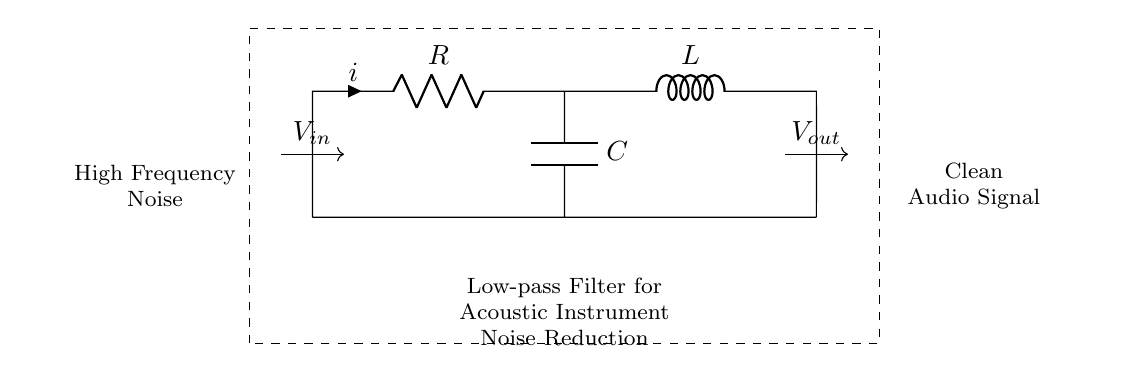What are the components used in this circuit? The circuit consists of a resistor, an inductor, and a capacitor, commonly found in low-pass filters. Visually, they are labeled R, L, and C.
Answer: Resistor, Inductor, Capacitor What is the input signal type for this circuit? The input signal is labeled as V_in, and the diagram indicates it deals with high-frequency noise, suggesting it is an alternating current signal used in audio applications.
Answer: High-frequency noise Where is the output taken from in the circuit? The output is taken from V_out, which is positioned after the inductor in the circuit diagram, providing the cleaned signal.
Answer: After the inductor How does the inductor affect the circuit's frequency response? The inductor opposes changes in current, leading to a reduced response to high frequencies while allowing lower frequencies to pass through, characteristic of a low-pass filter's function.
Answer: Reduces high frequencies What is the primary function of this low-pass filter in acoustic amplification? The low-pass filter is designed to eliminate high-frequency noise to ensure the acoustic instrument's audio signal remains clean, enhancing its overall quality during amplification.
Answer: Noise reduction What happens to the voltage across the capacitor in this circuit during operation? The capacitor charges and discharges based on the input signal frequency; at low frequencies, it passes the voltage well, while at high frequencies, it effectively blocks it, creating a voltage drop across it.
Answer: Voltage varies with frequency 